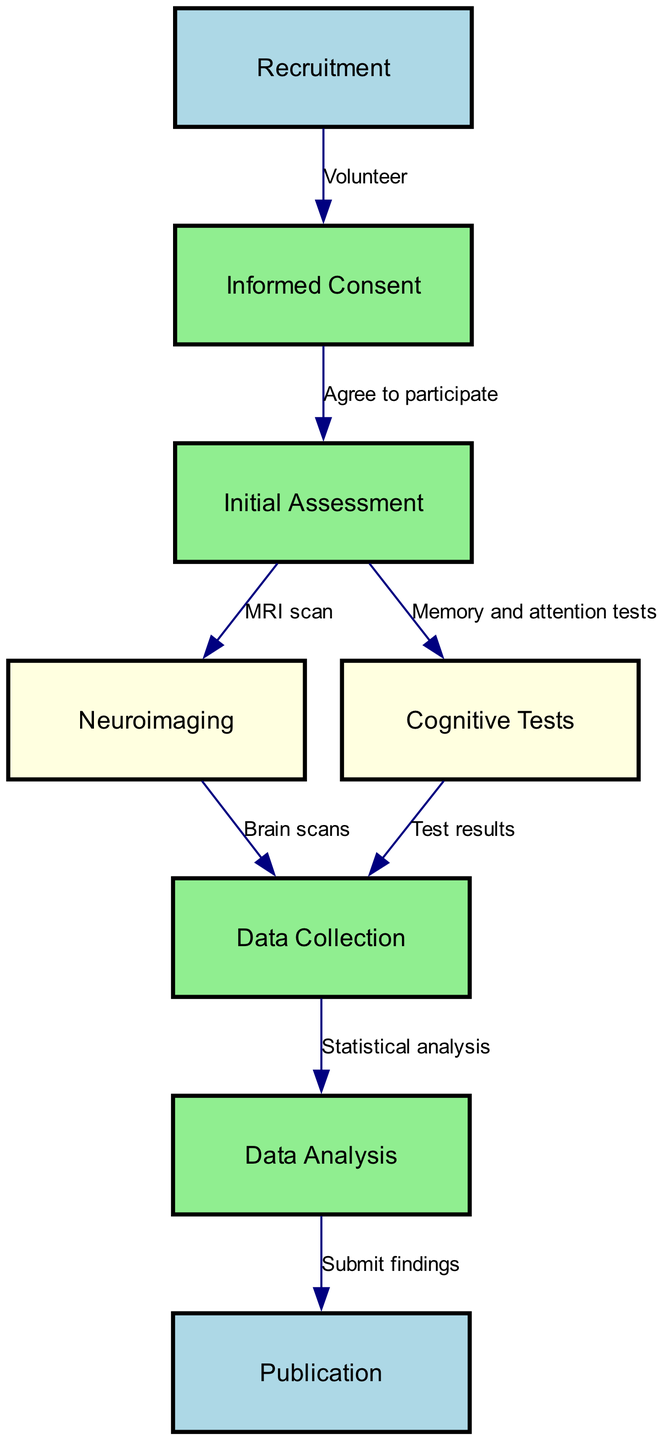What is the first step in the flowchart? The flowchart begins with the node labeled "Recruitment," indicating it is the first step in the process of participating in a scientific study on brain injury.
Answer: Recruitment How many nodes are present in the diagram? The diagram contains a total of eight nodes, which represent different stages in the study process. Counting the nodes listed: Recruitment, Informed Consent, Initial Assessment, Neuroimaging, Cognitive Tests, Data Collection, Data Analysis, and Publication confirms this.
Answer: 8 What is the label of the node that follows "Initial Assessment"? Following "Initial Assessment," there are two nodes, "Neuroimaging" and "Cognitive Tests," but since the question asks for the label of a single node, "Neuroimaging" is the first node after "Initial Assessment."
Answer: Neuroimaging Which node is linked to "Data Collection"? "Data Collection" is connected to the nodes labeled "Brain scans" and "Test results," which come from the nodes "Neuroimaging" and "Cognitive Tests" respectively. Therefore, both nodes lead into "Data Collection." Since the question is about a single link, either can be an appropriate answer, but we'll choose "Brain scans" as the first mentioned.
Answer: Brain scans What is the final step in the process? The final step in the flowchart is labeled "Publication," which indicates that after data analysis, the findings are submitted for publication.
Answer: Publication How does one progress from "Informed Consent" to "Initial Assessment"? To progress from "Informed Consent" to "Initial Assessment," a participant must agree to participate in the study, as indicated by the edge labeled "Agree to participate." Thus, this agreement is the necessary action that links these two nodes.
Answer: Agree to participate What type of analysis occurs after data collection? After data collection, the next step is "Data Analysis," which implies that a statistical method will be applied to the gathered data to derive conclusions. Therefore, the type of analysis referred to is statistical analysis.
Answer: Statistical analysis Which two nodes lead into "Data Collection"? The node "Data Collection" is preceded by "Brain scans" from the "Neuroimaging" node and "Test results" from the "Cognitive Tests" node. Hence, both these nodes contribute to the input for data collection.
Answer: Brain scans and Test results What is the relationship between "Data Analysis" and "Publication"? The relationship between "Data Analysis" and "Publication" is indicated by the edge labeled "Submit findings," which shows that after data analysis is completed, the results are submitted to be published. This demonstrates the flow from analyzing data to disseminating the results.
Answer: Submit findings 